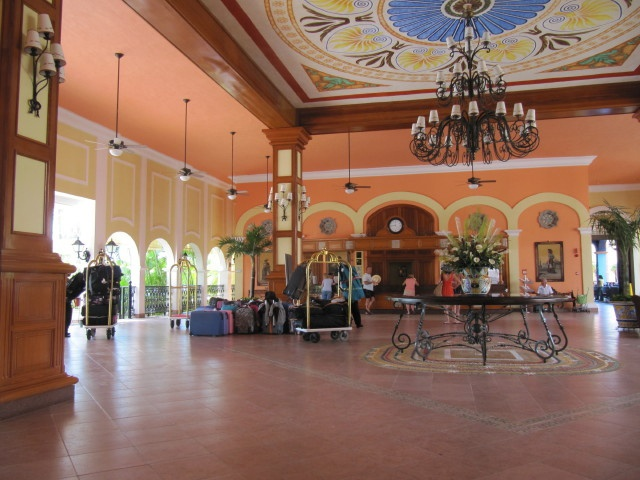Describe the objects in this image and their specific colors. I can see dining table in maroon, black, and gray tones, potted plant in maroon, black, olive, gray, and tan tones, potted plant in maroon, black, gray, and darkgreen tones, suitcase in maroon, black, gray, and brown tones, and potted plant in maroon, darkgreen, black, and gray tones in this image. 